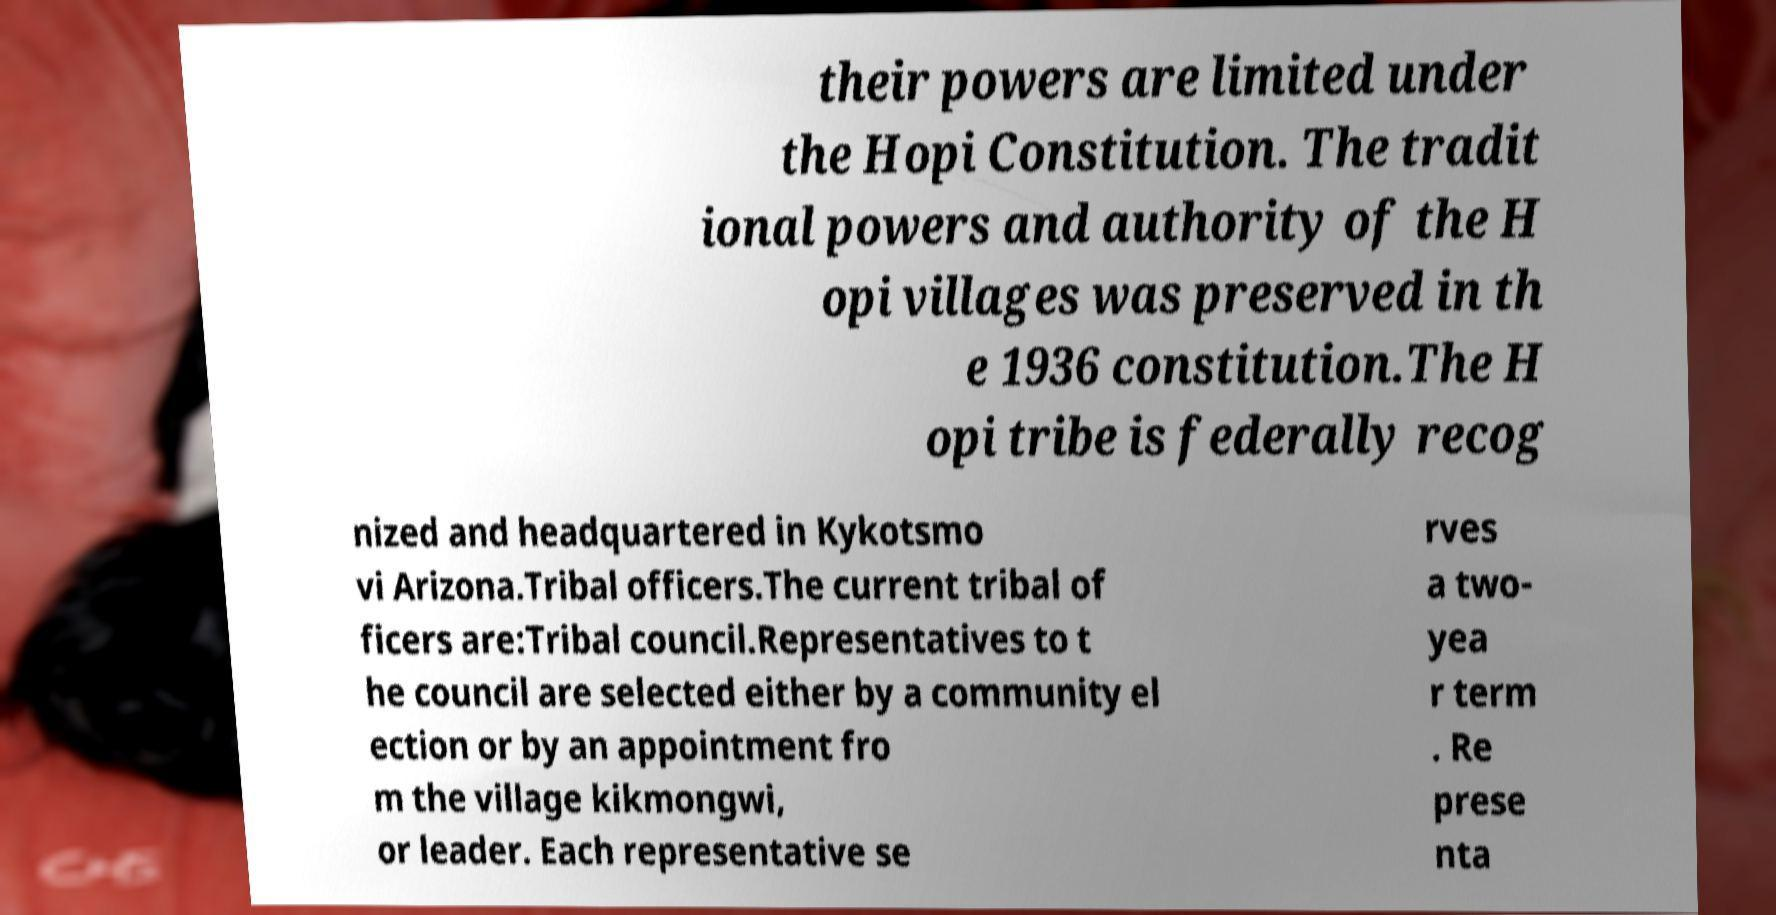Please read and relay the text visible in this image. What does it say? their powers are limited under the Hopi Constitution. The tradit ional powers and authority of the H opi villages was preserved in th e 1936 constitution.The H opi tribe is federally recog nized and headquartered in Kykotsmo vi Arizona.Tribal officers.The current tribal of ficers are:Tribal council.Representatives to t he council are selected either by a community el ection or by an appointment fro m the village kikmongwi, or leader. Each representative se rves a two- yea r term . Re prese nta 